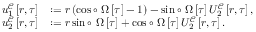<formula> <loc_0><loc_0><loc_500><loc_500>\begin{array} { r l } { u _ { 1 } ^ { \mathcal { C } } \left [ r , \tau \right ] } & { \colon = r \left ( \cos \circ \Omega \left [ \tau \right ] - 1 \right ) - \sin \circ \Omega \left [ \tau \right ] U _ { 2 } ^ { \mathcal { C } } \left [ r , \tau \right ] , } \\ { u _ { 2 } ^ { \mathcal { C } } \left [ r , \tau \right ] } & { \colon = r \sin \circ \Omega \left [ \tau \right ] + \cos \circ \Omega \left [ \tau \right ] U _ { 2 } ^ { \mathcal { C } } \left [ r , \tau \right ] . } \end{array}</formula> 